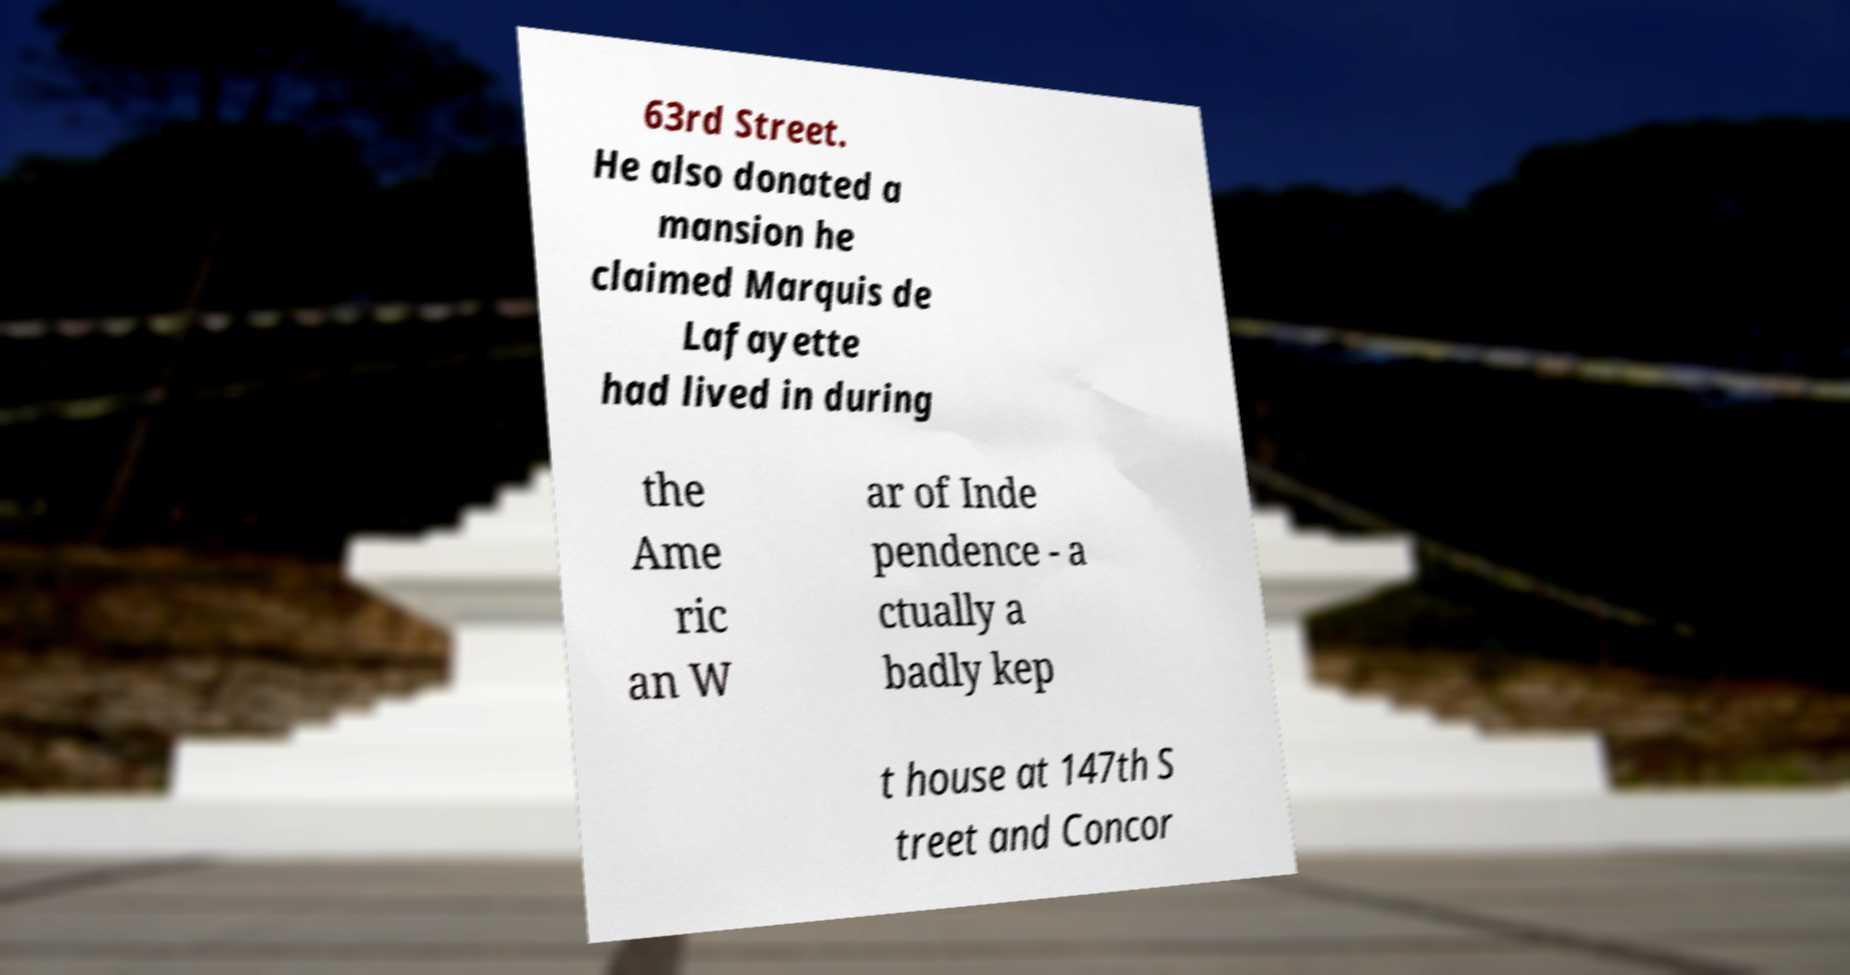There's text embedded in this image that I need extracted. Can you transcribe it verbatim? 63rd Street. He also donated a mansion he claimed Marquis de Lafayette had lived in during the Ame ric an W ar of Inde pendence - a ctually a badly kep t house at 147th S treet and Concor 